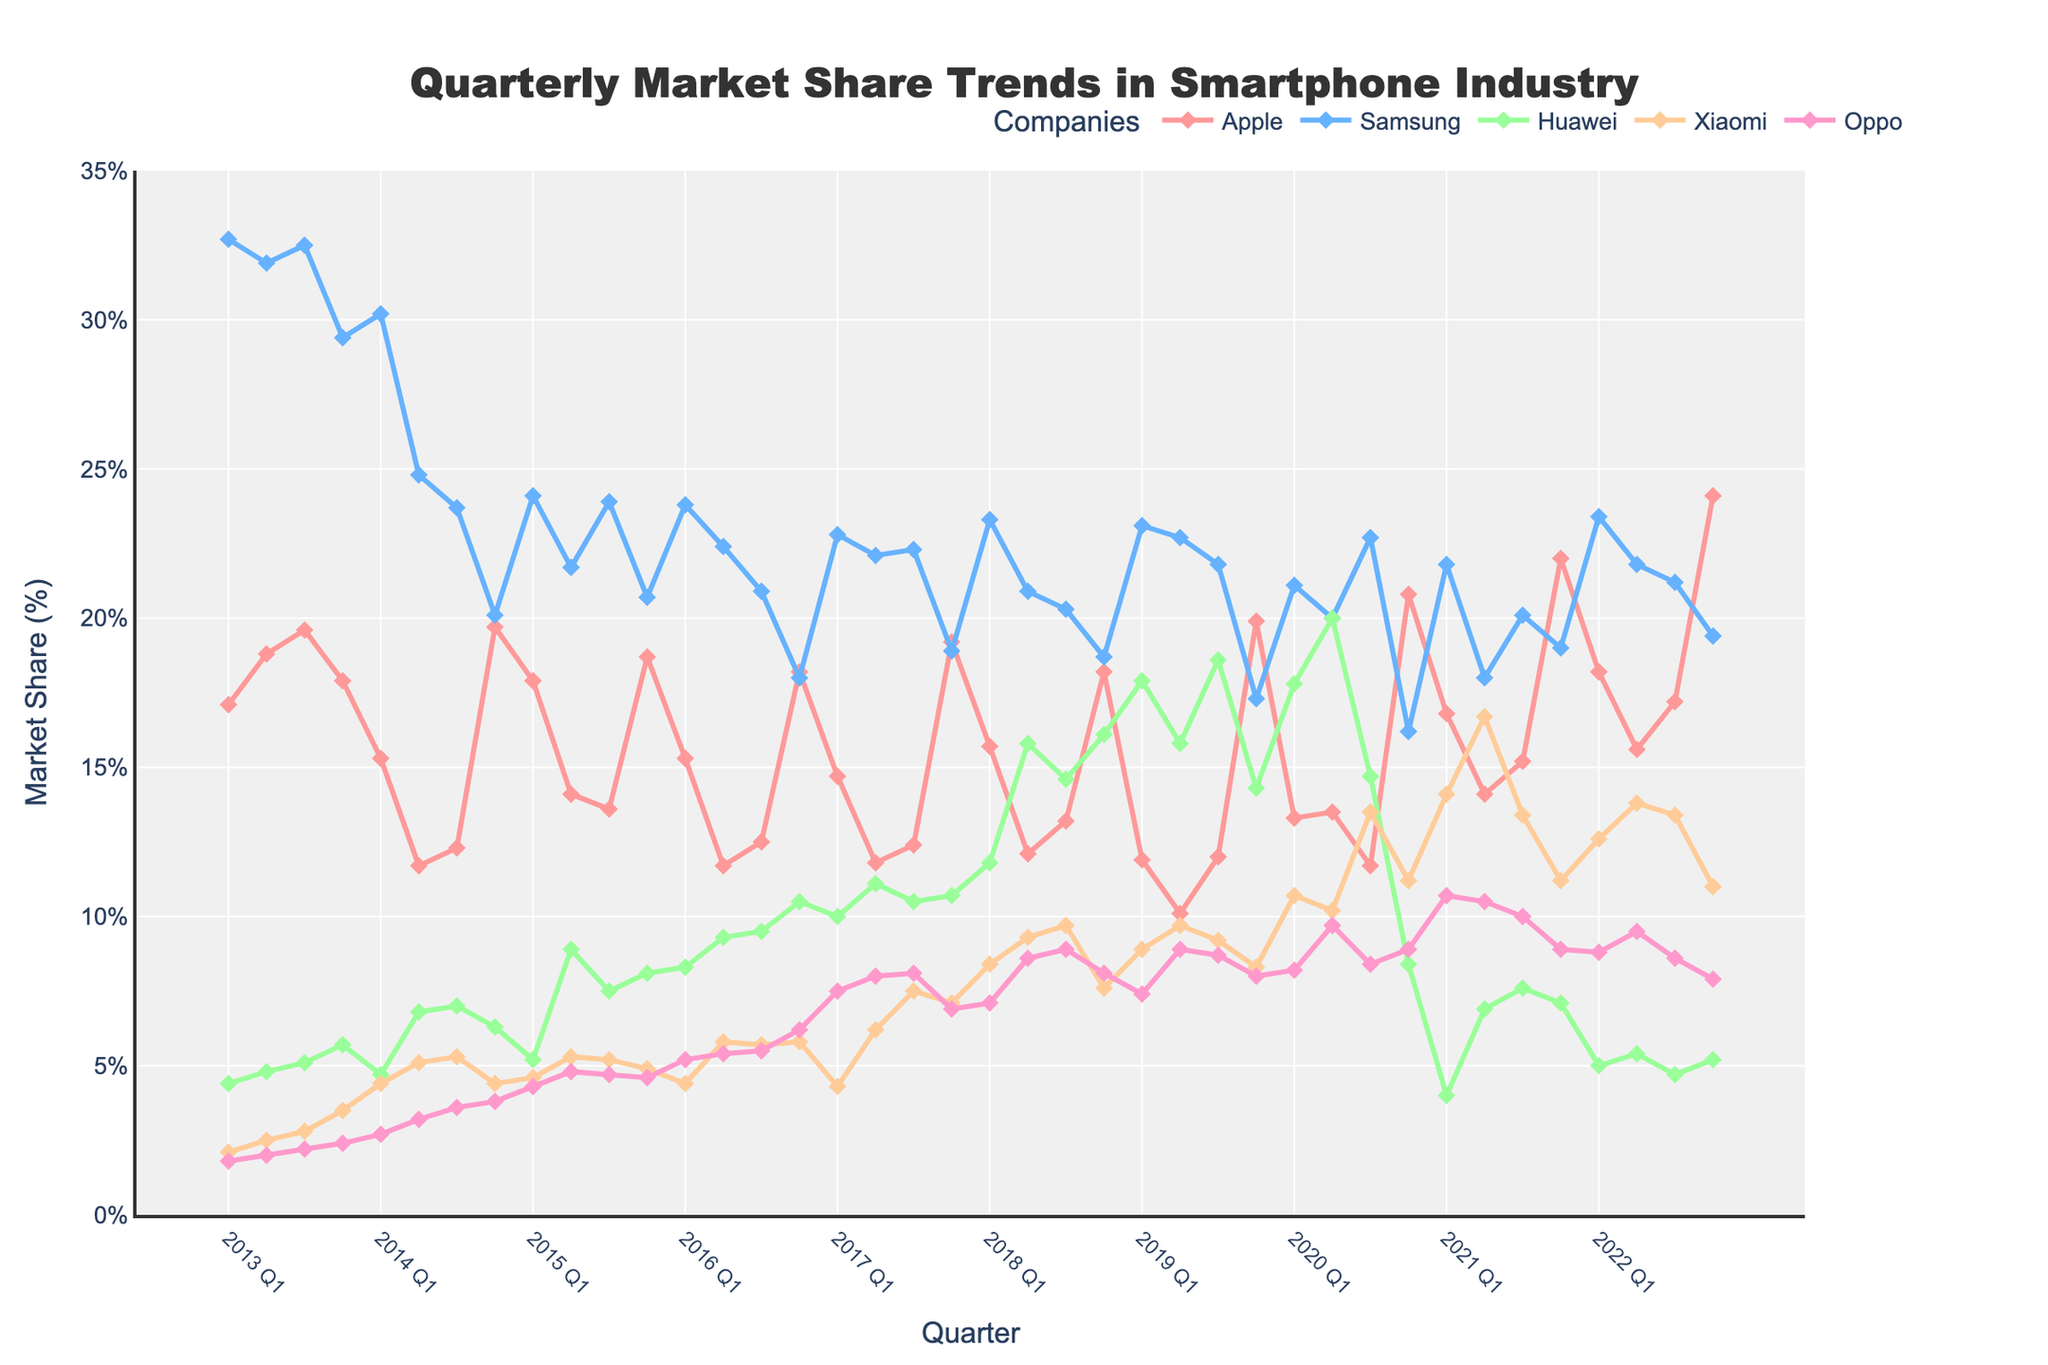What's the highest market share Apple achieved? Look for the highest peak in Apple's trend line on the chart. The highest point is at the end of 2022 Q4 where it reaches 24.1%.
Answer: 24.1% Which company had the lowest market share in 2013 Q4? Compare the market shares for all companies in 2013 Q4. The lowest market share is Oppo with 2.4%.
Answer: Oppo Which quarter did Xiaomi surpass Huawei in market share for the first time? Observe the trend lines of Xiaomi and Huawei and find the first intersection point. In 2020 Q3, Xiaomi's market share (13.5%) is higher than Huawei's (14.7%).
Answer: 2020 Q3 During which quarter(s) did Samsung and Huawei have the same market share? Look for the points where the lines for Samsung and Huawei intersect. In 2022 Q1, both Samsung and Huawei have a market share of 23.4%.
Answer: 2022 Q1 How many times did Apple's market share peak at over 20%? Count the number of peaks in Apple's trend line that exceed 20%. Apple's market share exceeds 20% in 2014 Q4, 2016 Q4, 2017 Q4, 2019 Q4, 2020 Q4, 2021 Q4, and 2022 Q4, making a total of 7 times.
Answer: 7 Between 2018 and 2019, did Huawei's market share increase or decrease, and by how much? Compare Huawei's market share at the end of 2018 (16.1% in Q4) and at the end of 2019 (14.3% in Q4). The difference is 16.1% - 14.3% = 1.8%. This is a decrease.
Answer: Decrease by 1.8% Which company showed the most consistent performance over the last decade? Look for a trend line that fluctuates the least. Samsung's line appears relatively stable around 20-30%.
Answer: Samsung Did Oppo's market share ever surpass 10%? If so, when? Look for points where Oppo's line crosses the 10% threshold. Oppo's market share surpasses 10% in 2020 Q1 (10.7%), 2021 Q1 (10.7%), and 2021 Q2 (10.5%).
Answer: Yes, in 2020 Q1, 2021 Q1, and 2021 Q2 What is the average market share of Xiaomi over the period of 2020? Average the market share values of Xiaomi for 2020: (10.7% + 10.2% + 13.5% + 11.2%) / 4 = 11.4%.
Answer: 11.4% 